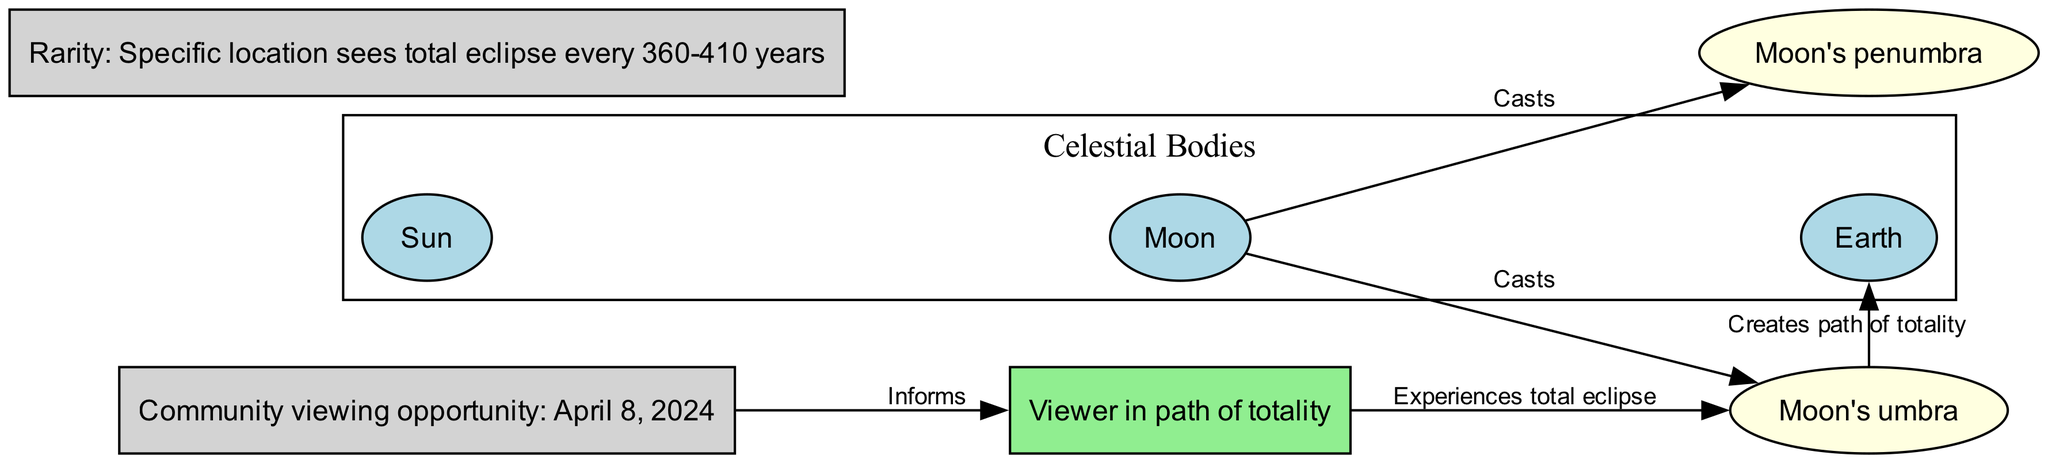What is the label for the node that represents the viewer? The diagram has a specific node labeled "Viewer in path of totality." This node is explicitly mentioned among the nodes listed.
Answer: Viewer in path of totality How many main celestial bodies are shown in the diagram? The diagram displays three main celestial bodies: the sun, the moon, and the earth. This can be determined by counting the nodes labeled as these celestial bodies.
Answer: 3 What relationship is indicated by the edge between the moon and the umbra? The diagram indicates a relationship where the moon "Casts" the umbra, making it clear through the directed edge labeled as such.
Answer: Casts When is the next community viewing opportunity for a solar eclipse? The diagram specifically states that the next community viewing opportunity is on "April 8, 2024." This can be found in the labeled node regarding community viewing.
Answer: April 8, 2024 What does the rarity node indicate regarding the visibility of total eclipses? The rarity node indicates that a specific location sees a total eclipse every "360-410 years." This information is directly tied to the rarity of witnessing a total eclipse in any one location.
Answer: 360-410 years Who experiences the total eclipse according to the diagram? The diagram specifies that the "Viewer in path of totality" experiences the total eclipse. This is indicated by the edge connecting the viewer to the umbra, which represents the area of total eclipse.
Answer: Viewer in path of totality How does the umbra affect the earth? The diagram indicates that the umbra "Creates path of totality" on the earth, which illustrates how the shadow from the moon affects specific locations on the earth's surface during an eclipse.
Answer: Creates path of totality Which node informs the viewer about the community viewing opportunity? The diagram shows that the "Community viewing opportunity" node informs the "Viewer in path of totality." This relationship is depicted by the directed edge labeled "Informs."
Answer: Informs What type of eclipse does a viewer in the umbra experience? The viewer located in the path of the umbra experiences a "total eclipse," which is directly stated in the node labeled for the viewer's experience.
Answer: Total eclipse 